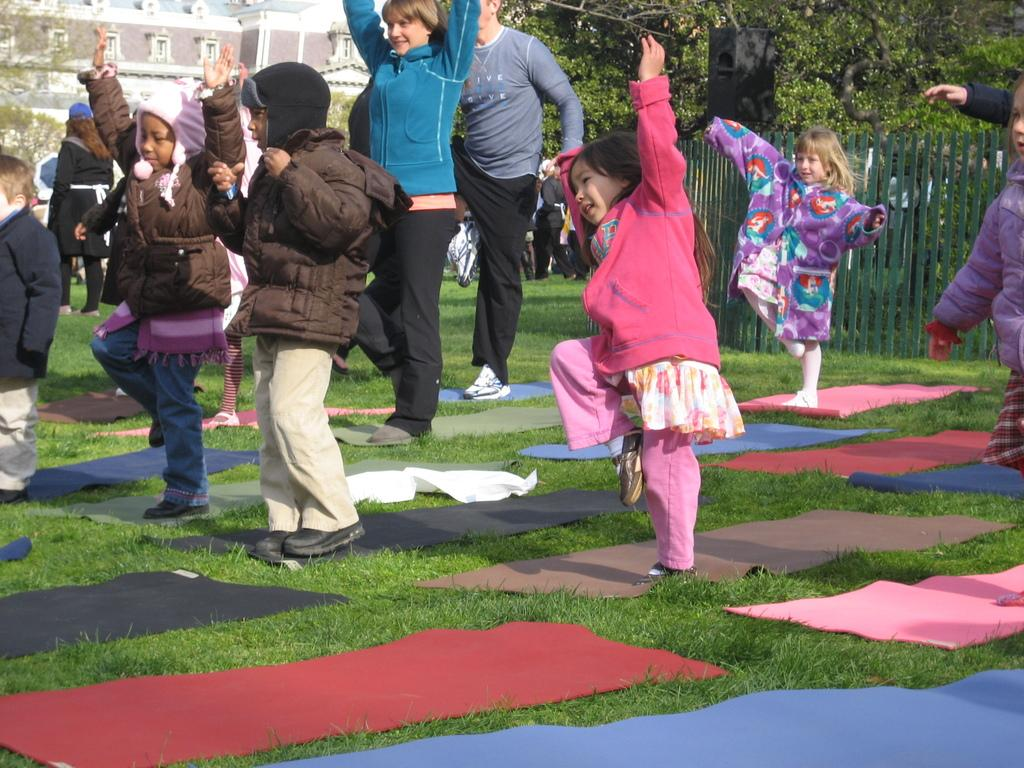Who is present in the image? There are children and people in the image. What are the children and people doing in the image? The presence of mats suggests that they might be participating in an activity, such as exercising or playing. What can be seen in the background of the image? There are trees and a building in the background of the image. What type of jellyfish can be seen swimming in the water in the image? There is no water or jellyfish present in the image; it features children, people, mats, trees, and a building. 